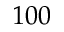Convert formula to latex. <formula><loc_0><loc_0><loc_500><loc_500>1 0 0</formula> 